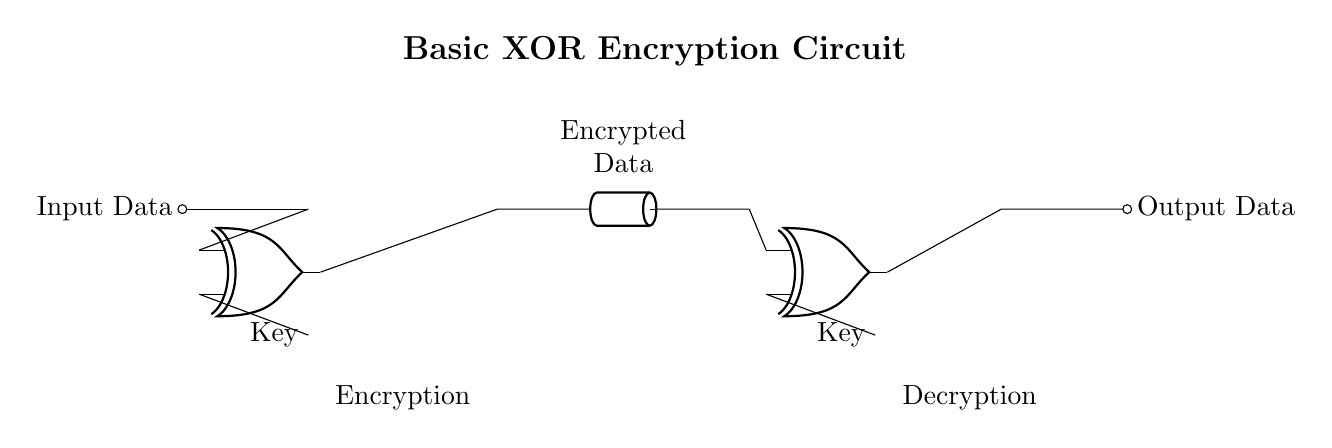What is the primary function of this circuit? The circuit encrypts input data using XOR gates to obfuscate it, making it unreadable without the key.
Answer: Encryption How many XOR gates are used in this circuit? There are two XOR gates present in the circuit, one for encryption and the other for decryption.
Answer: Two What is fed into the first XOR gate? The first XOR gate takes the input data and the key as its inputs to perform the encryption process.
Answer: Input data and key What is the output of the second XOR gate called? The output of the second XOR gate represents decrypted data, which is returned to its original format after XORing with the same key.
Answer: Output data What occurs between the first and second XOR gates? A transmission line is present between the first and second XOR gates, allowing encrypted data to be sent for decryption.
Answer: Transmission line Why is a key necessary in this circuit? The key is essential for both encryption and decryption since it determines how the data is altered by the XOR operation and allows retrieval of the original data.
Answer: To retrieve original data 